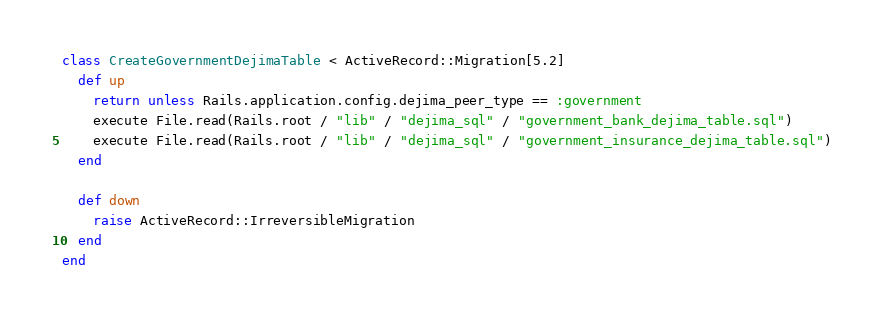<code> <loc_0><loc_0><loc_500><loc_500><_Ruby_>class CreateGovernmentDejimaTable < ActiveRecord::Migration[5.2]
  def up
    return unless Rails.application.config.dejima_peer_type == :government
    execute File.read(Rails.root / "lib" / "dejima_sql" / "government_bank_dejima_table.sql")
    execute File.read(Rails.root / "lib" / "dejima_sql" / "government_insurance_dejima_table.sql")
  end

  def down
    raise ActiveRecord::IrreversibleMigration
  end
end</code> 